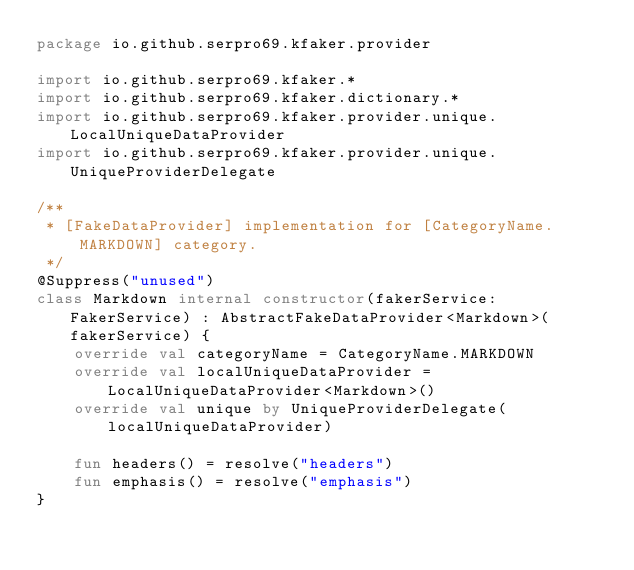Convert code to text. <code><loc_0><loc_0><loc_500><loc_500><_Kotlin_>package io.github.serpro69.kfaker.provider

import io.github.serpro69.kfaker.*
import io.github.serpro69.kfaker.dictionary.*
import io.github.serpro69.kfaker.provider.unique.LocalUniqueDataProvider
import io.github.serpro69.kfaker.provider.unique.UniqueProviderDelegate

/**
 * [FakeDataProvider] implementation for [CategoryName.MARKDOWN] category.
 */
@Suppress("unused")
class Markdown internal constructor(fakerService: FakerService) : AbstractFakeDataProvider<Markdown>(fakerService) {
    override val categoryName = CategoryName.MARKDOWN
    override val localUniqueDataProvider = LocalUniqueDataProvider<Markdown>()
    override val unique by UniqueProviderDelegate(localUniqueDataProvider)

    fun headers() = resolve("headers")
    fun emphasis() = resolve("emphasis")
}
</code> 